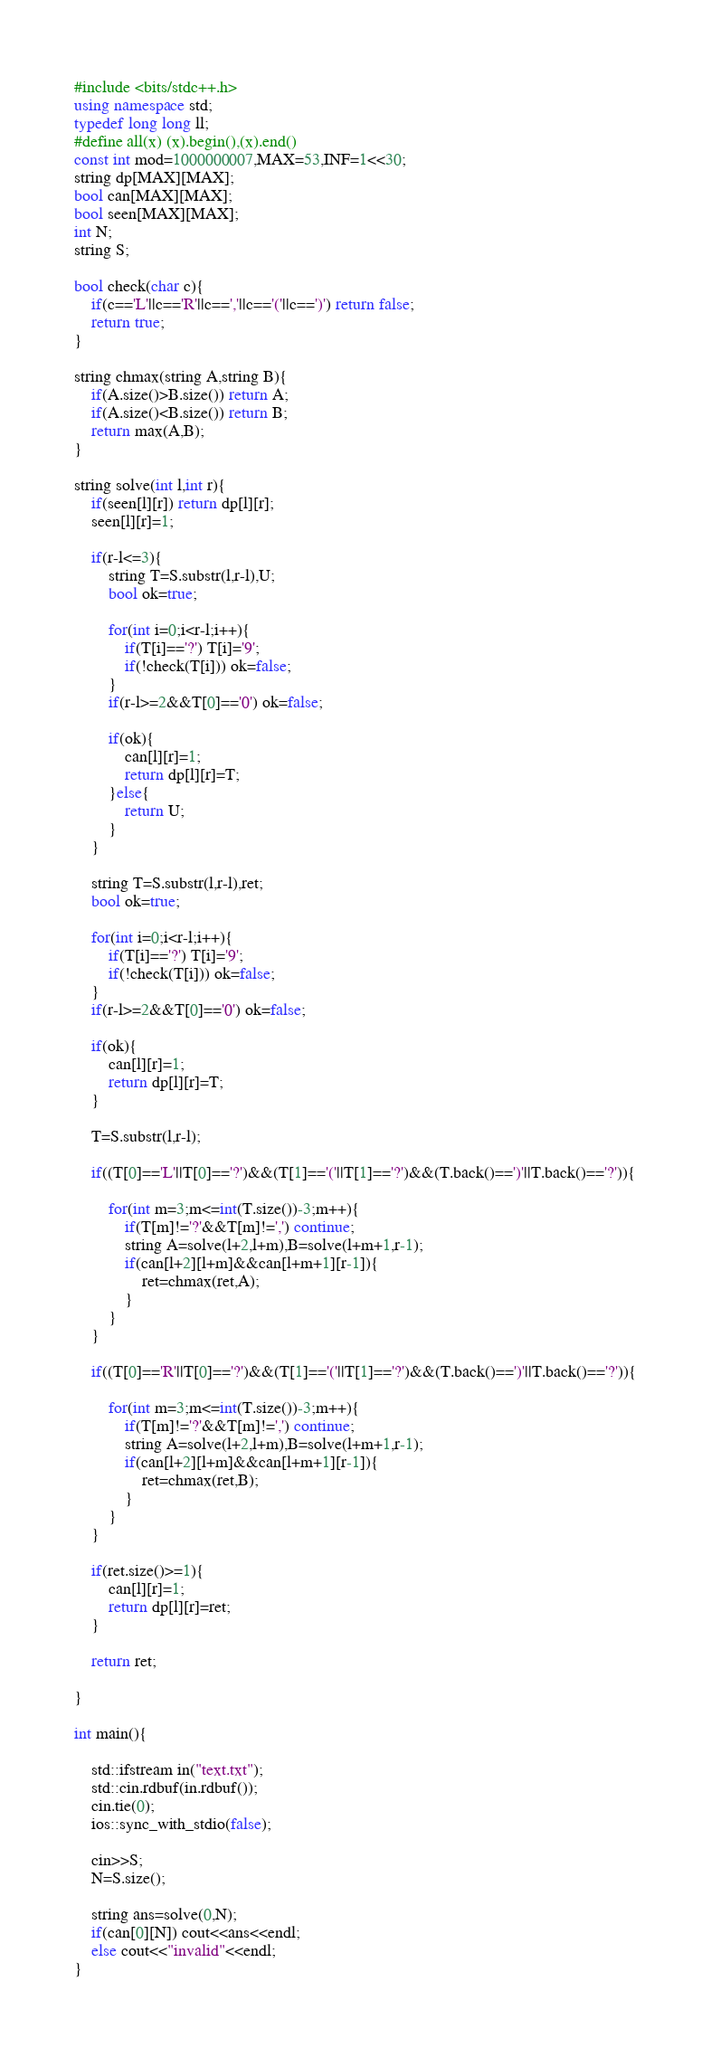Convert code to text. <code><loc_0><loc_0><loc_500><loc_500><_C++_>#include <bits/stdc++.h>
using namespace std;
typedef long long ll;
#define all(x) (x).begin(),(x).end()
const int mod=1000000007,MAX=53,INF=1<<30;
string dp[MAX][MAX];
bool can[MAX][MAX];
bool seen[MAX][MAX];
int N;
string S;

bool check(char c){
    if(c=='L'||c=='R'||c==','||c=='('||c==')') return false;
    return true;
}

string chmax(string A,string B){
    if(A.size()>B.size()) return A;
    if(A.size()<B.size()) return B;
    return max(A,B);
}

string solve(int l,int r){
    if(seen[l][r]) return dp[l][r];
    seen[l][r]=1;
    
    if(r-l<=3){
        string T=S.substr(l,r-l),U;
        bool ok=true;
        
        for(int i=0;i<r-l;i++){
            if(T[i]=='?') T[i]='9';
            if(!check(T[i])) ok=false;
        }
        if(r-l>=2&&T[0]=='0') ok=false;
        
        if(ok){
            can[l][r]=1;
            return dp[l][r]=T;
        }else{
            return U;
        }
    }
    
    string T=S.substr(l,r-l),ret;
    bool ok=true;
    
    for(int i=0;i<r-l;i++){
        if(T[i]=='?') T[i]='9';
        if(!check(T[i])) ok=false;
    }
    if(r-l>=2&&T[0]=='0') ok=false;
    
    if(ok){
        can[l][r]=1;
        return dp[l][r]=T;
    }
    
    T=S.substr(l,r-l);
    
    if((T[0]=='L'||T[0]=='?')&&(T[1]=='('||T[1]=='?')&&(T.back()==')'||T.back()=='?')){
        
        for(int m=3;m<=int(T.size())-3;m++){
            if(T[m]!='?'&&T[m]!=',') continue;
            string A=solve(l+2,l+m),B=solve(l+m+1,r-1);
            if(can[l+2][l+m]&&can[l+m+1][r-1]){
                ret=chmax(ret,A);
            }
        }
    }
    
    if((T[0]=='R'||T[0]=='?')&&(T[1]=='('||T[1]=='?')&&(T.back()==')'||T.back()=='?')){
        
        for(int m=3;m<=int(T.size())-3;m++){
            if(T[m]!='?'&&T[m]!=',') continue;
            string A=solve(l+2,l+m),B=solve(l+m+1,r-1);
            if(can[l+2][l+m]&&can[l+m+1][r-1]){
                ret=chmax(ret,B);
            }
        }
    }
    
    if(ret.size()>=1){
        can[l][r]=1;
        return dp[l][r]=ret;
    }
    
    return ret;
    
}

int main(){
    
    std::ifstream in("text.txt");
    std::cin.rdbuf(in.rdbuf());
    cin.tie(0);
    ios::sync_with_stdio(false);
    
    cin>>S;
    N=S.size();
    
    string ans=solve(0,N);
    if(can[0][N]) cout<<ans<<endl;
    else cout<<"invalid"<<endl;
}


</code> 